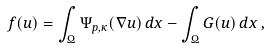Convert formula to latex. <formula><loc_0><loc_0><loc_500><loc_500>f ( u ) = \int _ { \Omega } \Psi _ { p , \kappa } ( \nabla u ) \, d x - \int _ { \Omega } G ( u ) \, d x \, ,</formula> 